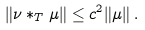Convert formula to latex. <formula><loc_0><loc_0><loc_500><loc_500>\| \nu * _ { T } \mu \| \leq c ^ { 2 } \| \mu \| \, .</formula> 